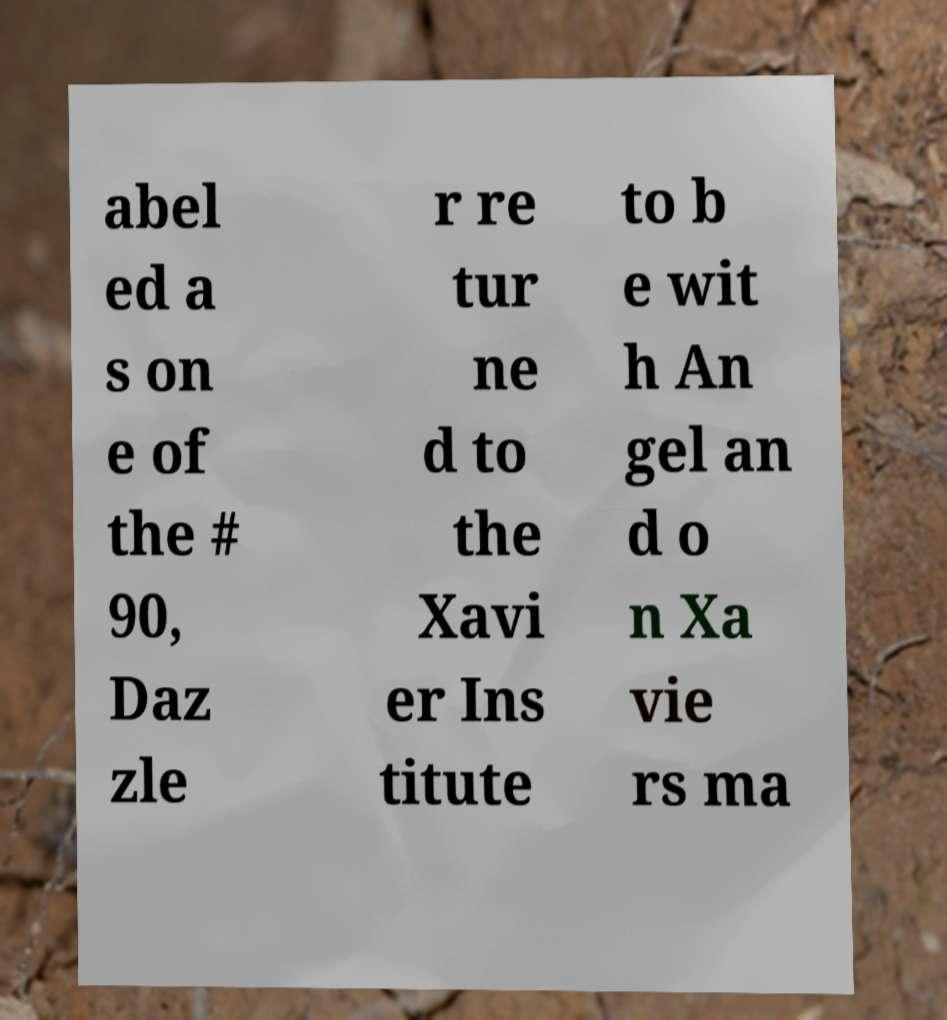Please identify and transcribe the text found in this image. abel ed a s on e of the # 90, Daz zle r re tur ne d to the Xavi er Ins titute to b e wit h An gel an d o n Xa vie rs ma 